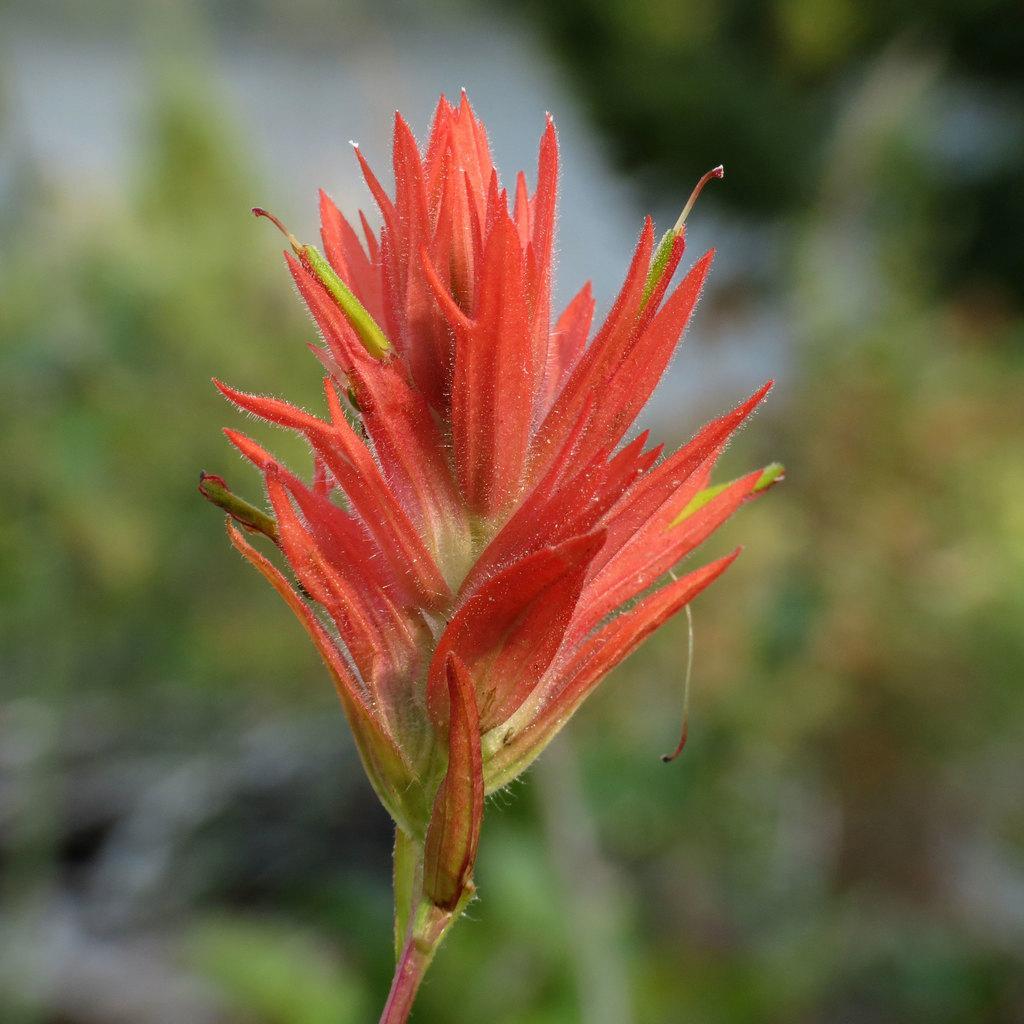How would you summarize this image in a sentence or two? In the center of the image we can see a flower. 